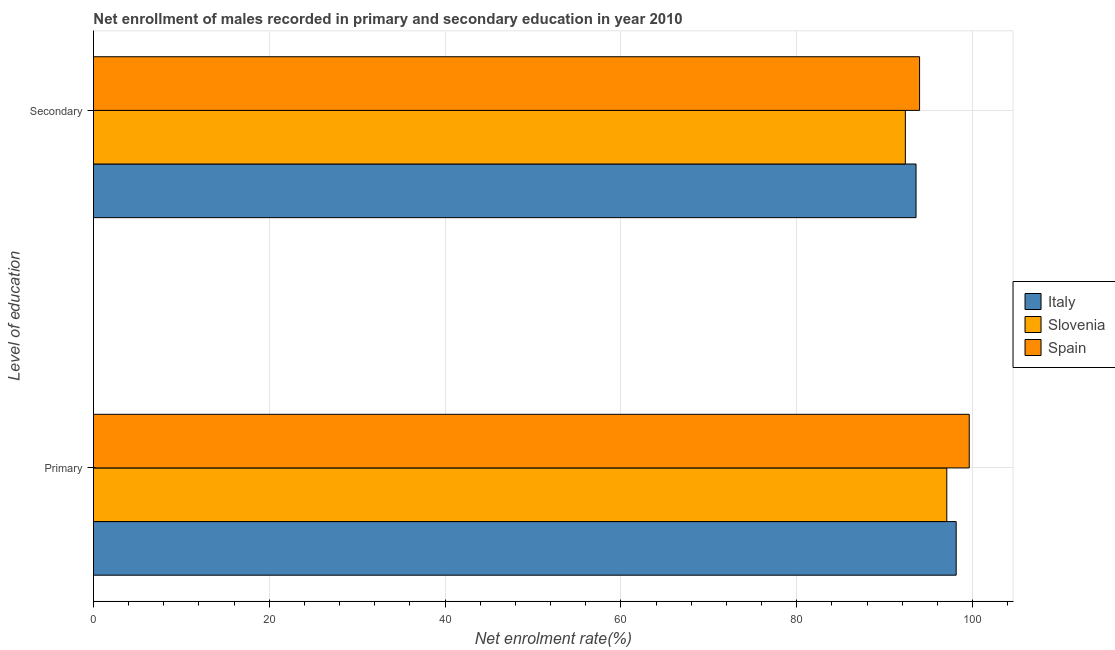Are the number of bars per tick equal to the number of legend labels?
Your answer should be very brief. Yes. What is the label of the 2nd group of bars from the top?
Make the answer very short. Primary. What is the enrollment rate in secondary education in Italy?
Keep it short and to the point. 93.57. Across all countries, what is the maximum enrollment rate in primary education?
Your answer should be very brief. 99.62. Across all countries, what is the minimum enrollment rate in primary education?
Ensure brevity in your answer.  97.07. In which country was the enrollment rate in primary education minimum?
Ensure brevity in your answer.  Slovenia. What is the total enrollment rate in primary education in the graph?
Your answer should be very brief. 294.82. What is the difference between the enrollment rate in primary education in Slovenia and that in Italy?
Your answer should be compact. -1.07. What is the difference between the enrollment rate in secondary education in Italy and the enrollment rate in primary education in Slovenia?
Your answer should be very brief. -3.5. What is the average enrollment rate in primary education per country?
Make the answer very short. 98.27. What is the difference between the enrollment rate in secondary education and enrollment rate in primary education in Slovenia?
Your answer should be very brief. -4.71. In how many countries, is the enrollment rate in primary education greater than 100 %?
Give a very brief answer. 0. What is the ratio of the enrollment rate in secondary education in Italy to that in Spain?
Give a very brief answer. 1. Is the enrollment rate in secondary education in Spain less than that in Slovenia?
Offer a terse response. No. What does the 2nd bar from the bottom in Secondary represents?
Your answer should be compact. Slovenia. How many bars are there?
Offer a very short reply. 6. Are the values on the major ticks of X-axis written in scientific E-notation?
Provide a short and direct response. No. Does the graph contain any zero values?
Ensure brevity in your answer.  No. How many legend labels are there?
Make the answer very short. 3. What is the title of the graph?
Ensure brevity in your answer.  Net enrollment of males recorded in primary and secondary education in year 2010. Does "North America" appear as one of the legend labels in the graph?
Make the answer very short. No. What is the label or title of the X-axis?
Provide a succinct answer. Net enrolment rate(%). What is the label or title of the Y-axis?
Provide a short and direct response. Level of education. What is the Net enrolment rate(%) of Italy in Primary?
Offer a very short reply. 98.13. What is the Net enrolment rate(%) of Slovenia in Primary?
Make the answer very short. 97.07. What is the Net enrolment rate(%) of Spain in Primary?
Offer a terse response. 99.62. What is the Net enrolment rate(%) in Italy in Secondary?
Provide a succinct answer. 93.57. What is the Net enrolment rate(%) of Slovenia in Secondary?
Ensure brevity in your answer.  92.35. What is the Net enrolment rate(%) in Spain in Secondary?
Make the answer very short. 93.97. Across all Level of education, what is the maximum Net enrolment rate(%) in Italy?
Provide a short and direct response. 98.13. Across all Level of education, what is the maximum Net enrolment rate(%) of Slovenia?
Give a very brief answer. 97.07. Across all Level of education, what is the maximum Net enrolment rate(%) in Spain?
Your answer should be compact. 99.62. Across all Level of education, what is the minimum Net enrolment rate(%) in Italy?
Give a very brief answer. 93.57. Across all Level of education, what is the minimum Net enrolment rate(%) in Slovenia?
Offer a very short reply. 92.35. Across all Level of education, what is the minimum Net enrolment rate(%) in Spain?
Your answer should be very brief. 93.97. What is the total Net enrolment rate(%) in Italy in the graph?
Offer a terse response. 191.7. What is the total Net enrolment rate(%) of Slovenia in the graph?
Your response must be concise. 189.42. What is the total Net enrolment rate(%) of Spain in the graph?
Keep it short and to the point. 193.59. What is the difference between the Net enrolment rate(%) in Italy in Primary and that in Secondary?
Offer a terse response. 4.57. What is the difference between the Net enrolment rate(%) in Slovenia in Primary and that in Secondary?
Give a very brief answer. 4.71. What is the difference between the Net enrolment rate(%) in Spain in Primary and that in Secondary?
Your answer should be compact. 5.65. What is the difference between the Net enrolment rate(%) of Italy in Primary and the Net enrolment rate(%) of Slovenia in Secondary?
Offer a very short reply. 5.78. What is the difference between the Net enrolment rate(%) in Italy in Primary and the Net enrolment rate(%) in Spain in Secondary?
Give a very brief answer. 4.16. What is the difference between the Net enrolment rate(%) of Slovenia in Primary and the Net enrolment rate(%) of Spain in Secondary?
Your answer should be compact. 3.1. What is the average Net enrolment rate(%) of Italy per Level of education?
Give a very brief answer. 95.85. What is the average Net enrolment rate(%) of Slovenia per Level of education?
Keep it short and to the point. 94.71. What is the average Net enrolment rate(%) of Spain per Level of education?
Provide a short and direct response. 96.8. What is the difference between the Net enrolment rate(%) in Italy and Net enrolment rate(%) in Slovenia in Primary?
Provide a short and direct response. 1.07. What is the difference between the Net enrolment rate(%) in Italy and Net enrolment rate(%) in Spain in Primary?
Ensure brevity in your answer.  -1.49. What is the difference between the Net enrolment rate(%) in Slovenia and Net enrolment rate(%) in Spain in Primary?
Provide a short and direct response. -2.55. What is the difference between the Net enrolment rate(%) of Italy and Net enrolment rate(%) of Slovenia in Secondary?
Your answer should be very brief. 1.21. What is the difference between the Net enrolment rate(%) in Italy and Net enrolment rate(%) in Spain in Secondary?
Offer a very short reply. -0.4. What is the difference between the Net enrolment rate(%) of Slovenia and Net enrolment rate(%) of Spain in Secondary?
Keep it short and to the point. -1.62. What is the ratio of the Net enrolment rate(%) in Italy in Primary to that in Secondary?
Offer a very short reply. 1.05. What is the ratio of the Net enrolment rate(%) in Slovenia in Primary to that in Secondary?
Ensure brevity in your answer.  1.05. What is the ratio of the Net enrolment rate(%) of Spain in Primary to that in Secondary?
Provide a succinct answer. 1.06. What is the difference between the highest and the second highest Net enrolment rate(%) of Italy?
Ensure brevity in your answer.  4.57. What is the difference between the highest and the second highest Net enrolment rate(%) in Slovenia?
Provide a short and direct response. 4.71. What is the difference between the highest and the second highest Net enrolment rate(%) in Spain?
Keep it short and to the point. 5.65. What is the difference between the highest and the lowest Net enrolment rate(%) in Italy?
Provide a succinct answer. 4.57. What is the difference between the highest and the lowest Net enrolment rate(%) of Slovenia?
Offer a terse response. 4.71. What is the difference between the highest and the lowest Net enrolment rate(%) of Spain?
Keep it short and to the point. 5.65. 